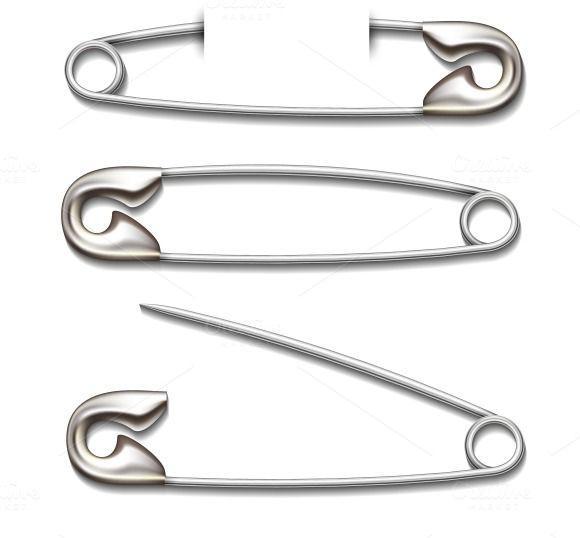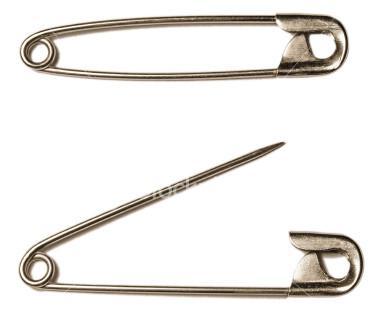The first image is the image on the left, the second image is the image on the right. Evaluate the accuracy of this statement regarding the images: "There are more pins in the image on the right.". Is it true? Answer yes or no. No. The first image is the image on the left, the second image is the image on the right. For the images displayed, is the sentence "An image shows overlapping safety pins." factually correct? Answer yes or no. No. 